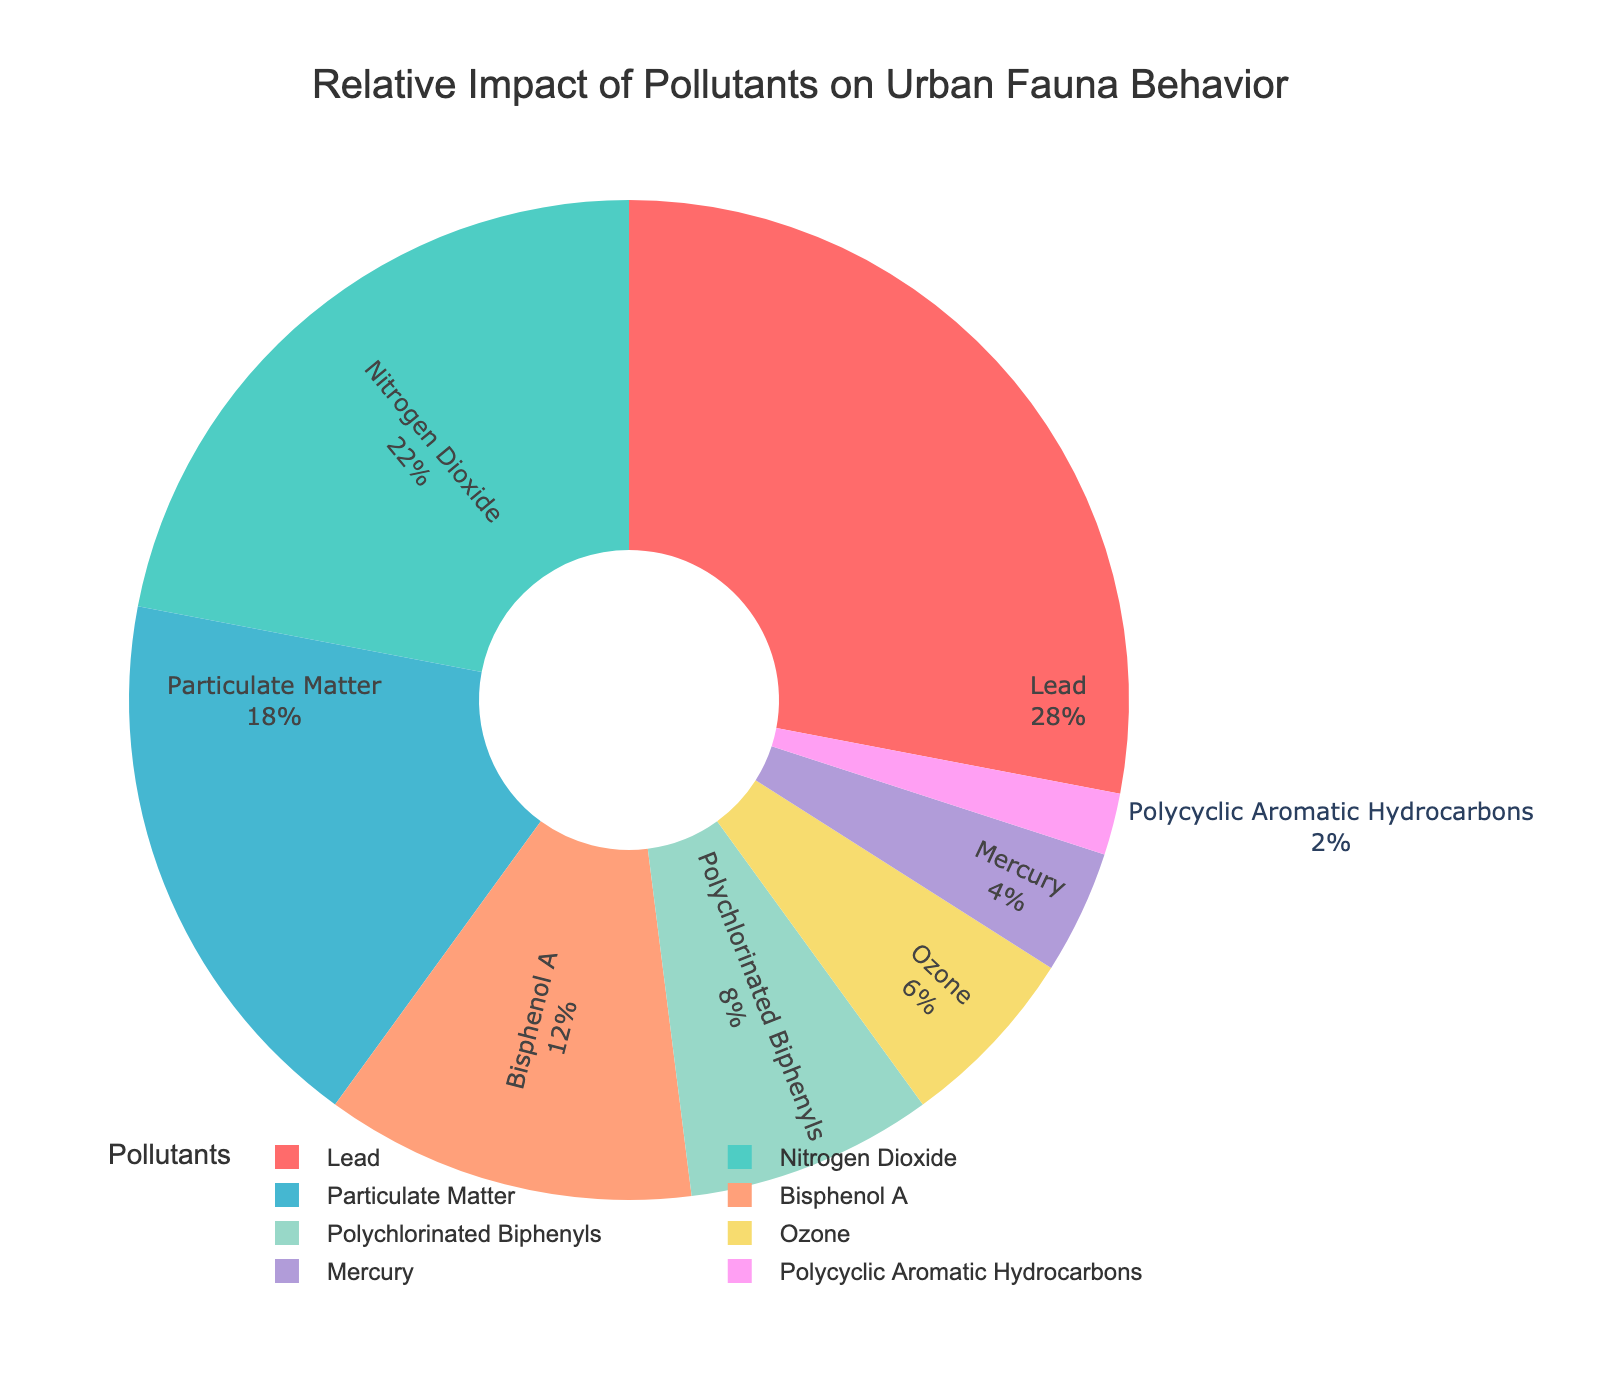What's the most impactful pollutant on urban fauna behavior? Look at the pie chart and see which pollutant occupies the largest segment. The largest segment is labeled "Lead" with 28% impact.
Answer: Lead Which pollutant has the smallest impact on urban fauna behavior? Identify the smallest segment in the pie chart. The smallest segment is labeled "Polycyclic Aromatic Hydrocarbons" with 2% impact.
Answer: Polycyclic Aromatic Hydrocarbons What is the combined impact percentage of Lead and Nitrogen Dioxide on urban fauna behavior? Sum the percentages of Lead and Nitrogen Dioxide from the chart: 28% (Lead) + 22% (Nitrogen Dioxide) = 50%.
Answer: 50% Which pollutant has a higher impact on urban fauna behavior, Ozone or Mercury? Compare the segments labeled "Ozone" and "Mercury". Ozone has 6% impact, while Mercury has 4%.
Answer: Ozone What is the average impact of the least three impactful pollutants on urban fauna behavior? Identify the smallest three segments: Polycyclic Aromatic Hydrocarbons (2%), Mercury (4%), and Ozone (6%). Calculate the average: (2 + 4 + 6) / 3 = 4.
Answer: 4 How much more impactful is Particulate Matter compared to Polychlorinated Biphenyls? Find the difference between the segments labeled "Particulate Matter" (18%) and "Polychlorinated Biphenyls" (8%). Calculate the difference: 18% - 8% = 10%.
Answer: 10% What is the combined contribution of Bisphenol A, Polychlorinated Biphenyls, and Ozone to urban fauna behavior? Add the percentages of Bisphenol A (12%), Polychlorinated Biphenyls (8%), and Ozone (6%): 12% + 8% + 6% = 26%.
Answer: 26% Which pollutant has a greater impact on urban fauna behavior, Bisphenol A or Particulate Matter? Compare the segments labeled "Bisphenol A" and "Particulate Matter". Particulate Matter has 18% impact, while Bisphenol A has 12%.
Answer: Particulate Matter What is the total impact percentage of pollutants with an impact greater than 20%? Sum the percentages of pollutants whose impact percentages are greater than 20%: Lead (28%) and Nitrogen Dioxide (22%). 28% + 22% = 50%.
Answer: 50% What color is used to represent Bisphenol A's impact on urban fauna behavior? Look at the color of the segment labeled "Bisphenol A" in the pie chart. It is labeled with a color resembling salmon or peach.
Answer: salmon 